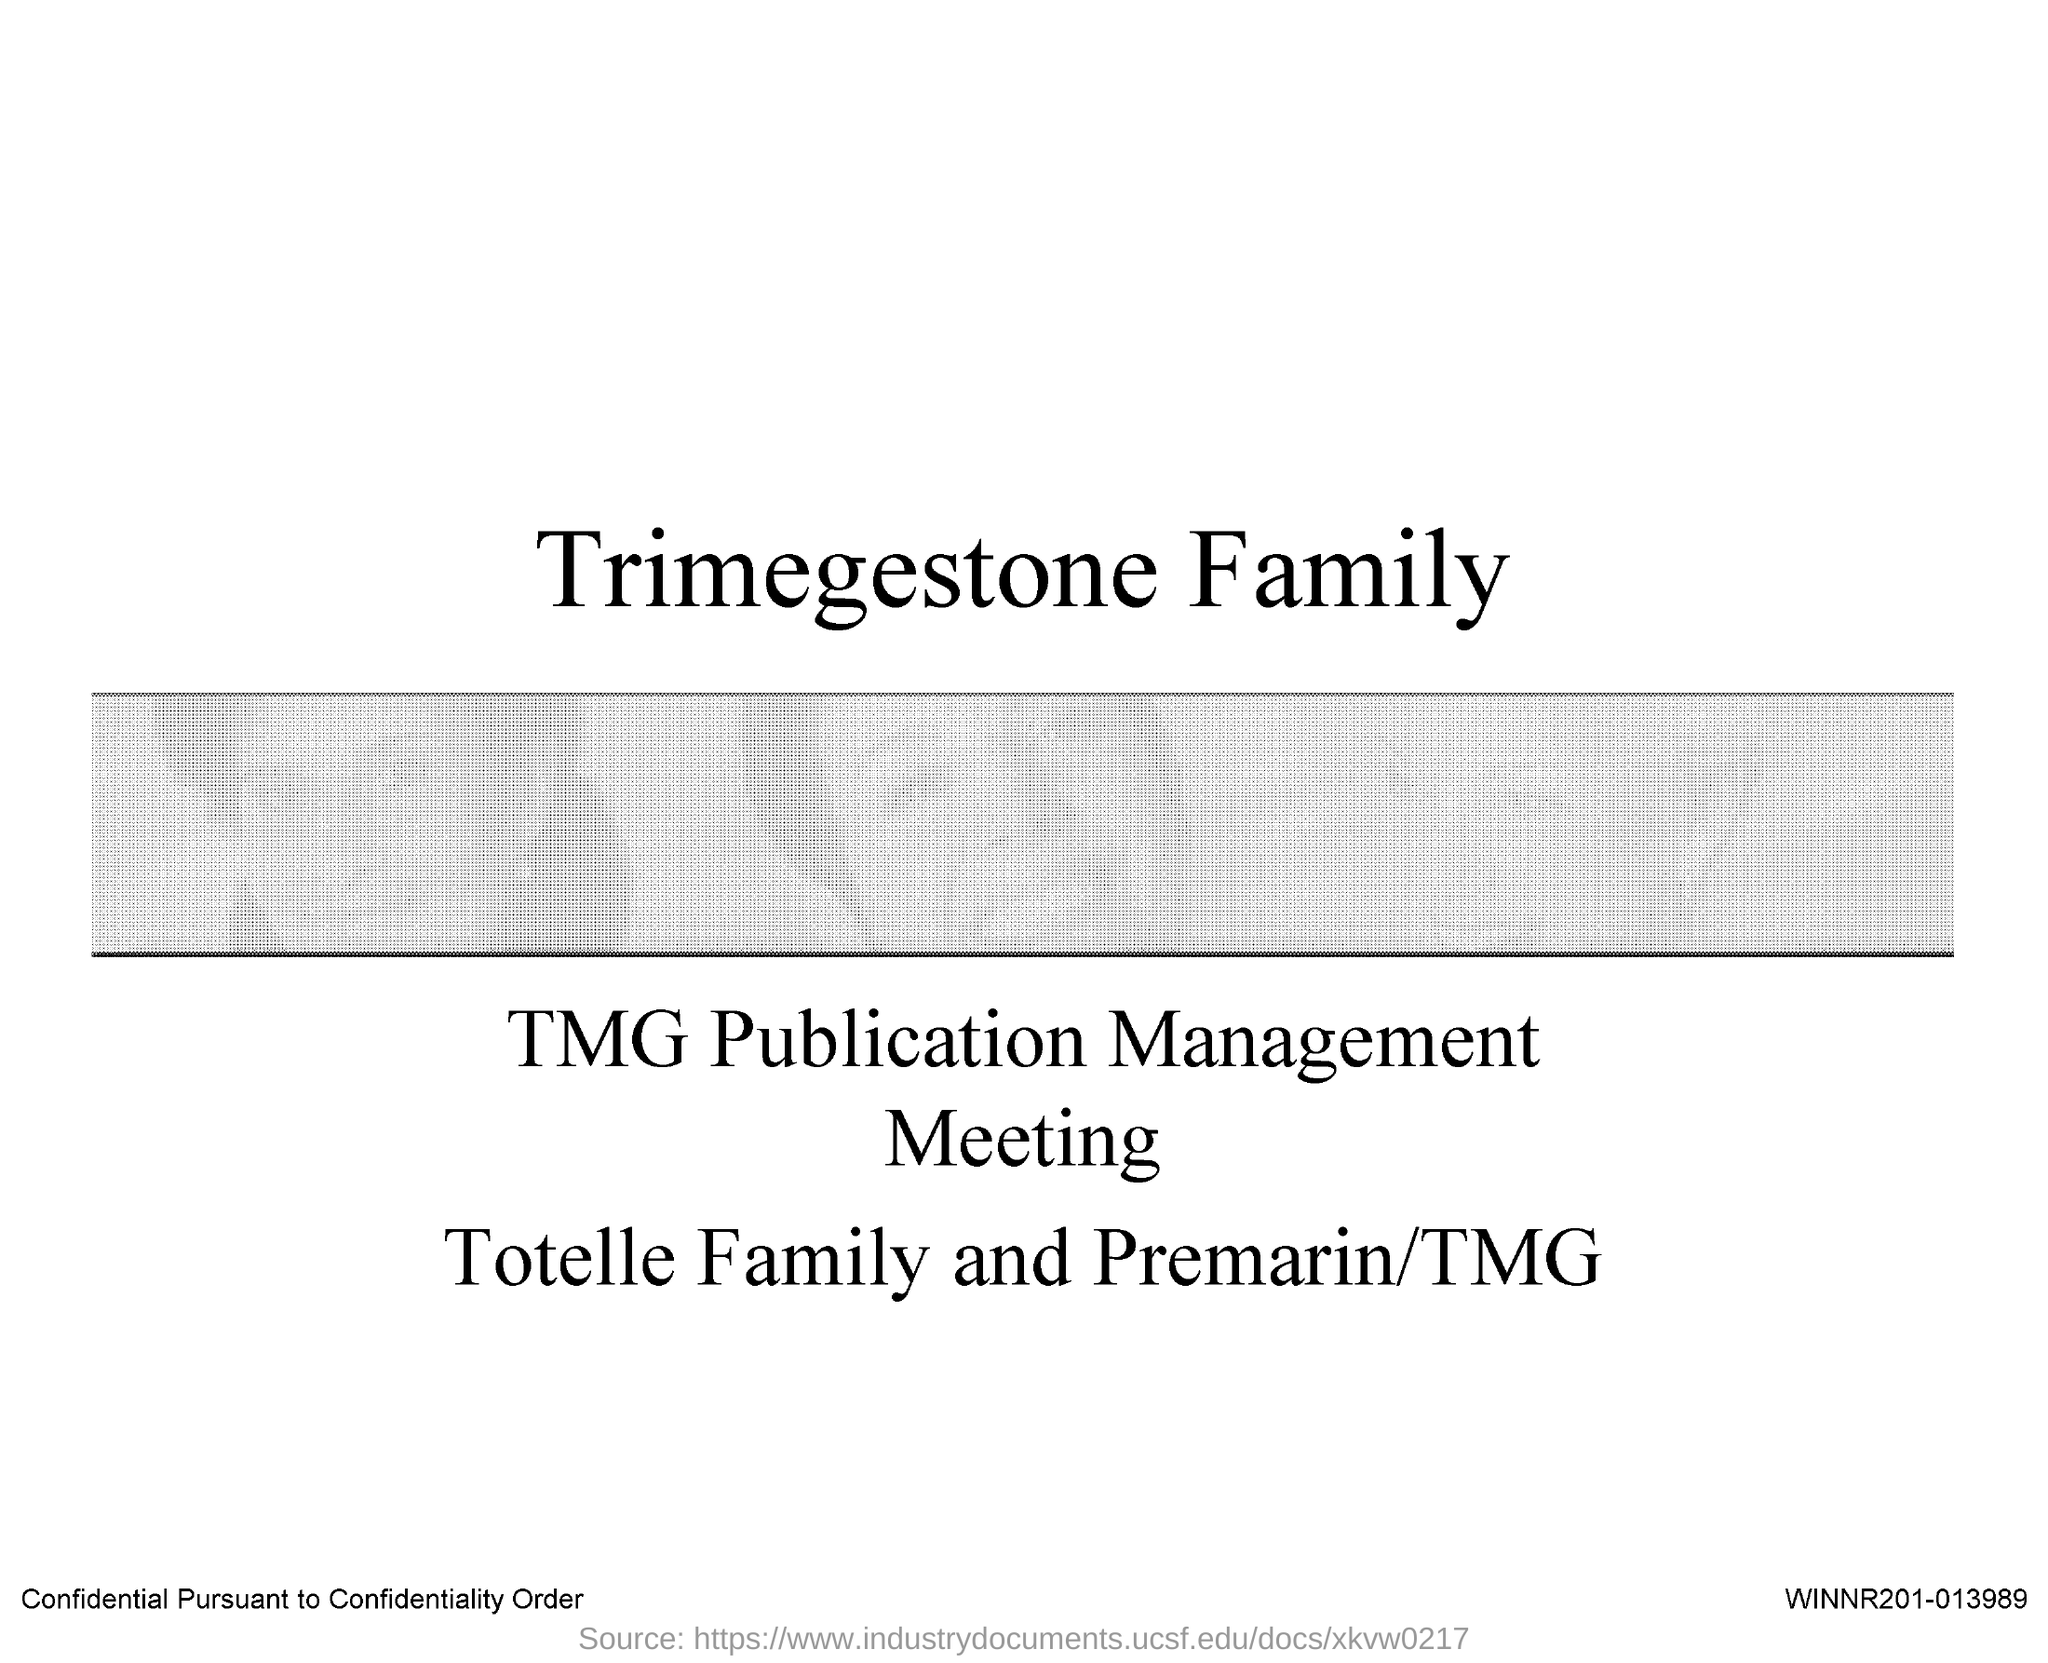What is the title of the document?
Keep it short and to the point. Trimegestone Family. 